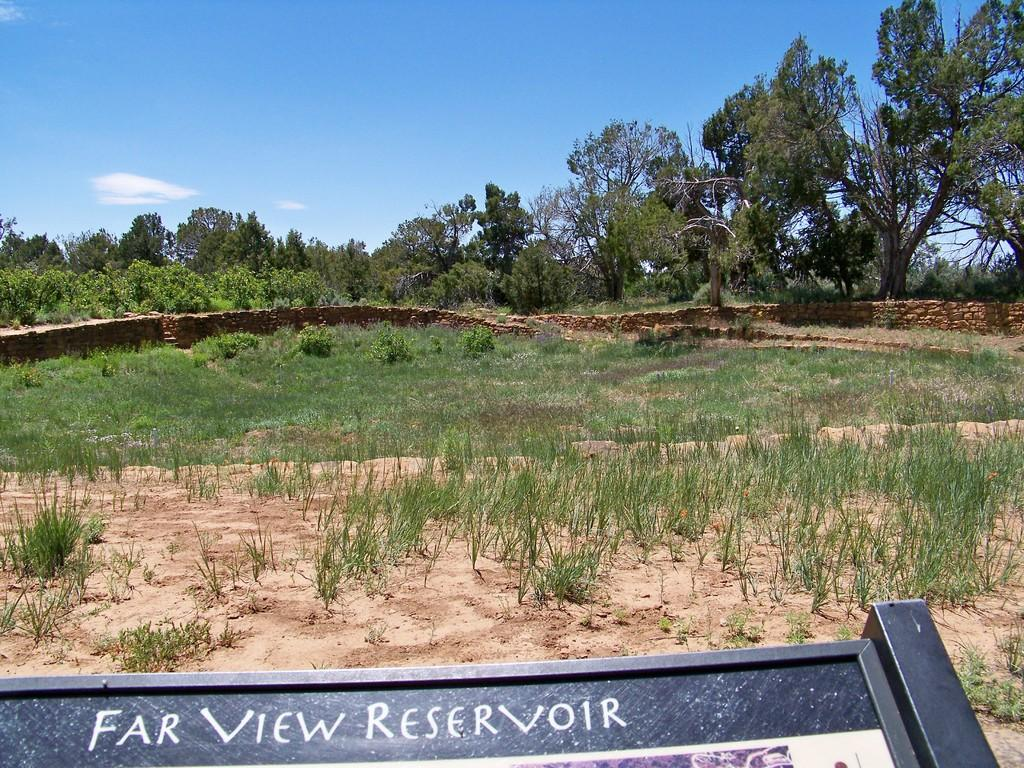What type of vegetation can be seen in the image? There is grass in the image. What part of the natural environment is visible in the image? The ground is visible in the image. What can be seen in the background of the image? There are trees in the image. What type of fencing is present in the image? There is stone fencing in the image. What is visible in the sky in the image? The sky is visible in the image, and clouds are present. What is located at the bottom of the image? There is a boat at the bottom of the image. What type of insurance does the grandfather have in the image? There is no grandfather or insurance mentioned or depicted in the image. 